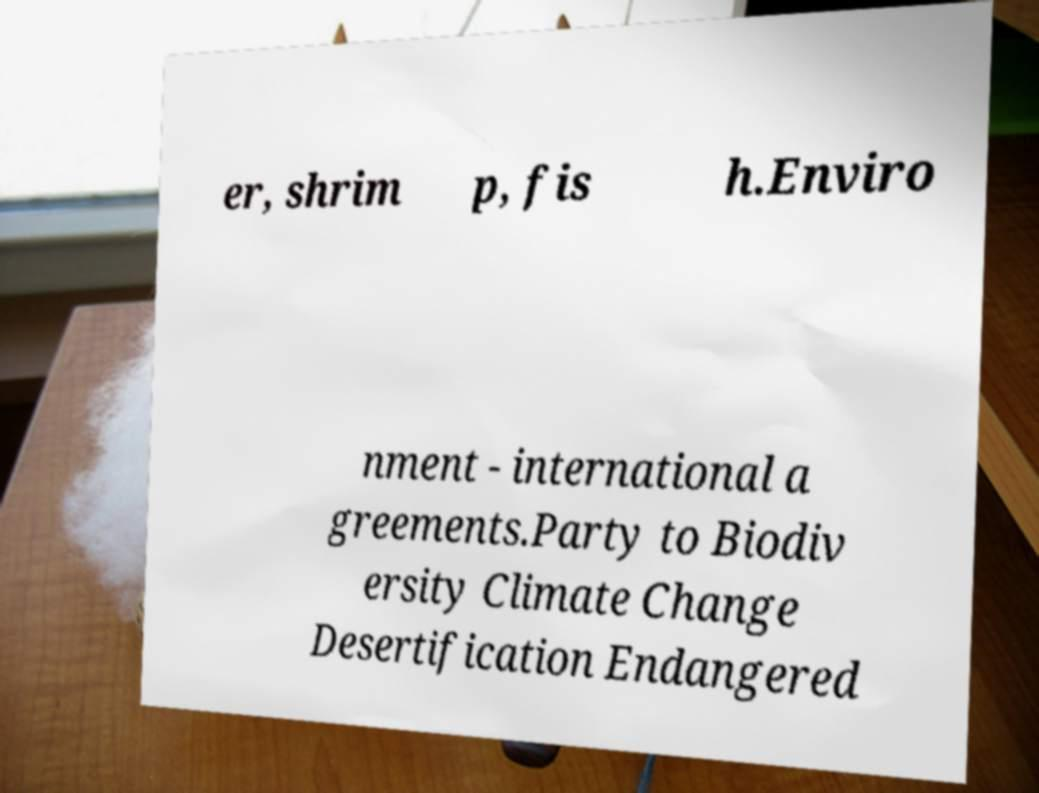Can you accurately transcribe the text from the provided image for me? er, shrim p, fis h.Enviro nment - international a greements.Party to Biodiv ersity Climate Change Desertification Endangered 